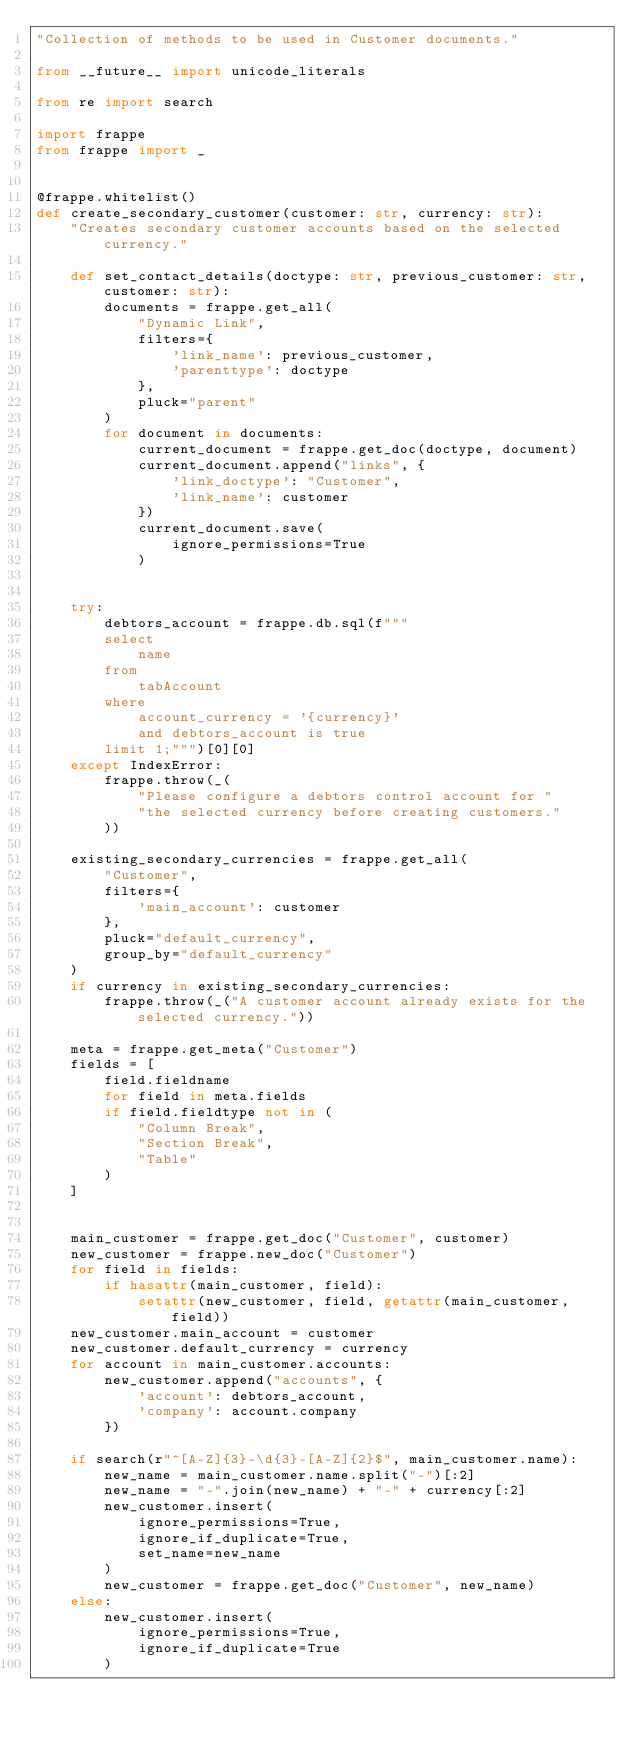<code> <loc_0><loc_0><loc_500><loc_500><_Python_>"Collection of methods to be used in Customer documents."

from __future__ import unicode_literals

from re import search

import frappe
from frappe import _


@frappe.whitelist()
def create_secondary_customer(customer: str, currency: str):
    "Creates secondary customer accounts based on the selected currency."

    def set_contact_details(doctype: str, previous_customer: str, customer: str):
        documents = frappe.get_all(
            "Dynamic Link",
            filters={
                'link_name': previous_customer,
                'parenttype': doctype
            },
            pluck="parent"
        )
        for document in documents:
            current_document = frappe.get_doc(doctype, document)
            current_document.append("links", {
                'link_doctype': "Customer",
                'link_name': customer
            })
            current_document.save(
                ignore_permissions=True
            )


    try:
        debtors_account = frappe.db.sql(f"""
        select
            name
        from
            tabAccount
        where
            account_currency = '{currency}'
            and debtors_account is true
        limit 1;""")[0][0]
    except IndexError:
        frappe.throw(_(
            "Please configure a debtors control account for "
            "the selected currency before creating customers."
        ))

    existing_secondary_currencies = frappe.get_all(
        "Customer",
        filters={
            'main_account': customer
        },
        pluck="default_currency",
        group_by="default_currency"
    )
    if currency in existing_secondary_currencies:
        frappe.throw(_("A customer account already exists for the selected currency."))

    meta = frappe.get_meta("Customer")
    fields = [
        field.fieldname
        for field in meta.fields
        if field.fieldtype not in (
            "Column Break",
            "Section Break",
            "Table"
        )
    ]


    main_customer = frappe.get_doc("Customer", customer)
    new_customer = frappe.new_doc("Customer")
    for field in fields:
        if hasattr(main_customer, field):
            setattr(new_customer, field, getattr(main_customer, field))
    new_customer.main_account = customer
    new_customer.default_currency = currency
    for account in main_customer.accounts:
        new_customer.append("accounts", {
            'account': debtors_account,
            'company': account.company
        })

    if search(r"^[A-Z]{3}-\d{3}-[A-Z]{2}$", main_customer.name):
        new_name = main_customer.name.split("-")[:2]
        new_name = "-".join(new_name) + "-" + currency[:2]
        new_customer.insert(
            ignore_permissions=True,
            ignore_if_duplicate=True,
            set_name=new_name
        )
        new_customer = frappe.get_doc("Customer", new_name)
    else:
        new_customer.insert(
            ignore_permissions=True,
            ignore_if_duplicate=True
        )
</code> 